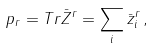<formula> <loc_0><loc_0><loc_500><loc_500>p _ { r } = T r \bar { Z } ^ { r } = \sum _ { i } \bar { z } ^ { r } _ { i } \, ,</formula> 